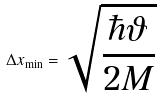<formula> <loc_0><loc_0><loc_500><loc_500>\Delta x _ { \min } = \sqrt { \frac { \hbar { \vartheta } } { 2 M } }</formula> 